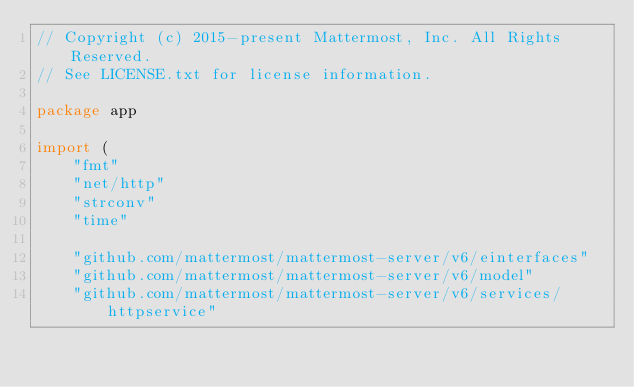<code> <loc_0><loc_0><loc_500><loc_500><_Go_>// Copyright (c) 2015-present Mattermost, Inc. All Rights Reserved.
// See LICENSE.txt for license information.

package app

import (
	"fmt"
	"net/http"
	"strconv"
	"time"

	"github.com/mattermost/mattermost-server/v6/einterfaces"
	"github.com/mattermost/mattermost-server/v6/model"
	"github.com/mattermost/mattermost-server/v6/services/httpservice"</code> 